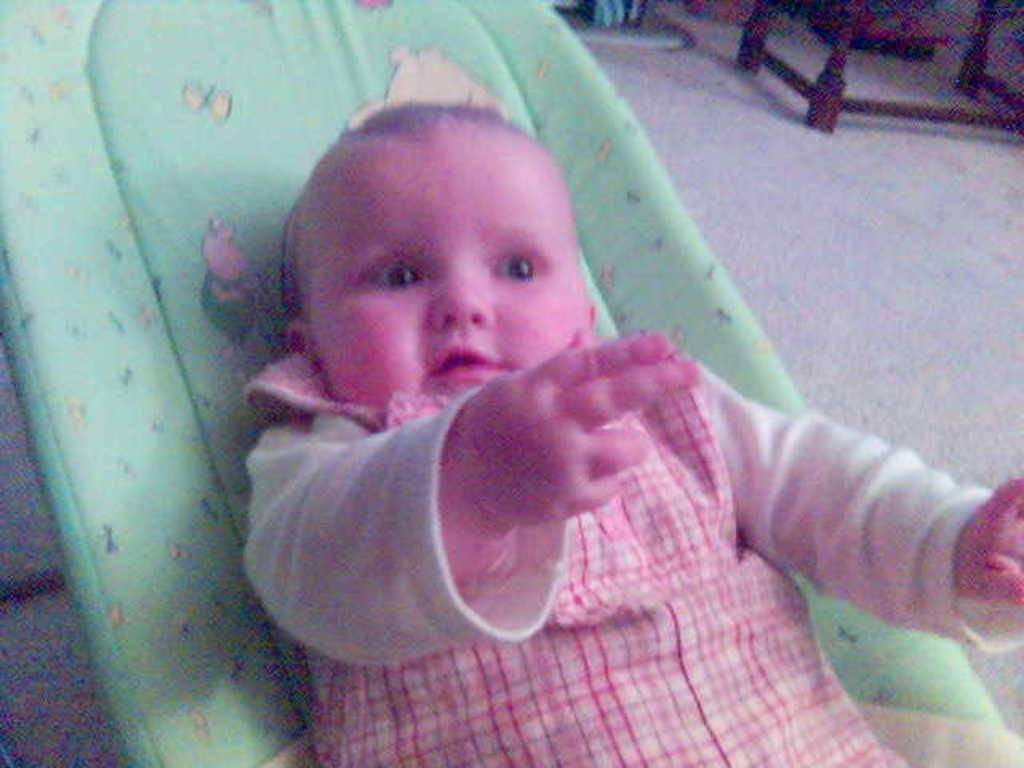What is the main subject of the image? The main subject of the image is a small baby. Where is the baby located in the image? The baby is in a cradle. What type of plate is being used to hold the cannon in the image? There is no plate or cannon present in the image. How much sugar is visible in the image? There is no sugar present in the image. 